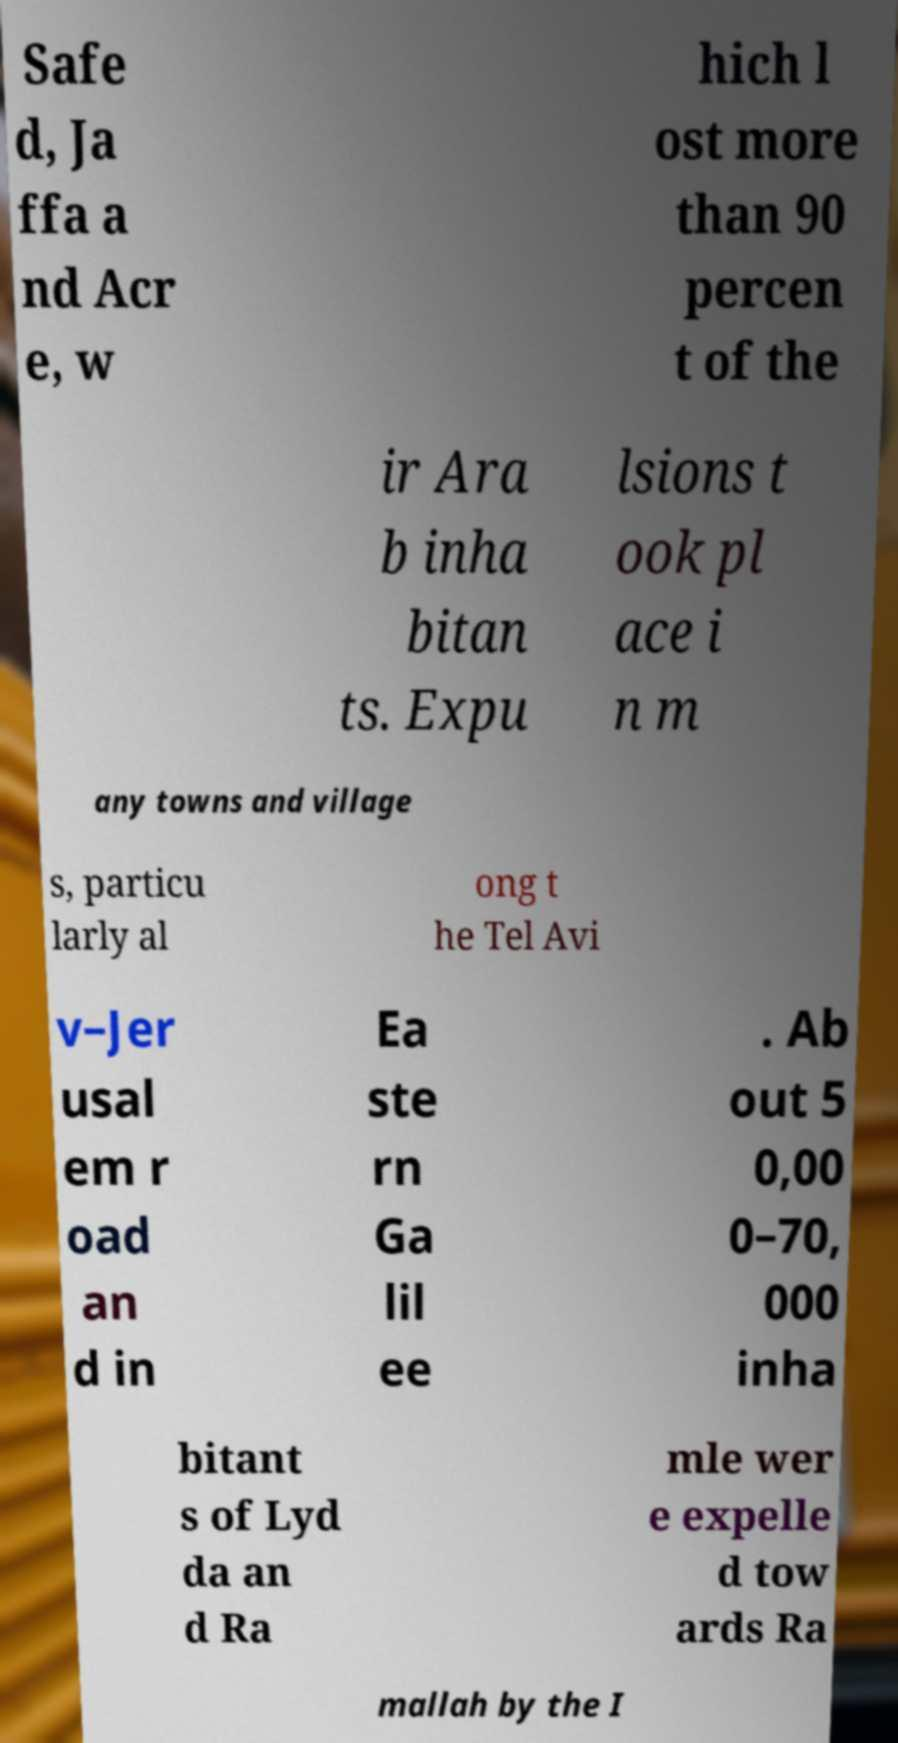Could you assist in decoding the text presented in this image and type it out clearly? Safe d, Ja ffa a nd Acr e, w hich l ost more than 90 percen t of the ir Ara b inha bitan ts. Expu lsions t ook pl ace i n m any towns and village s, particu larly al ong t he Tel Avi v–Jer usal em r oad an d in Ea ste rn Ga lil ee . Ab out 5 0,00 0–70, 000 inha bitant s of Lyd da an d Ra mle wer e expelle d tow ards Ra mallah by the I 